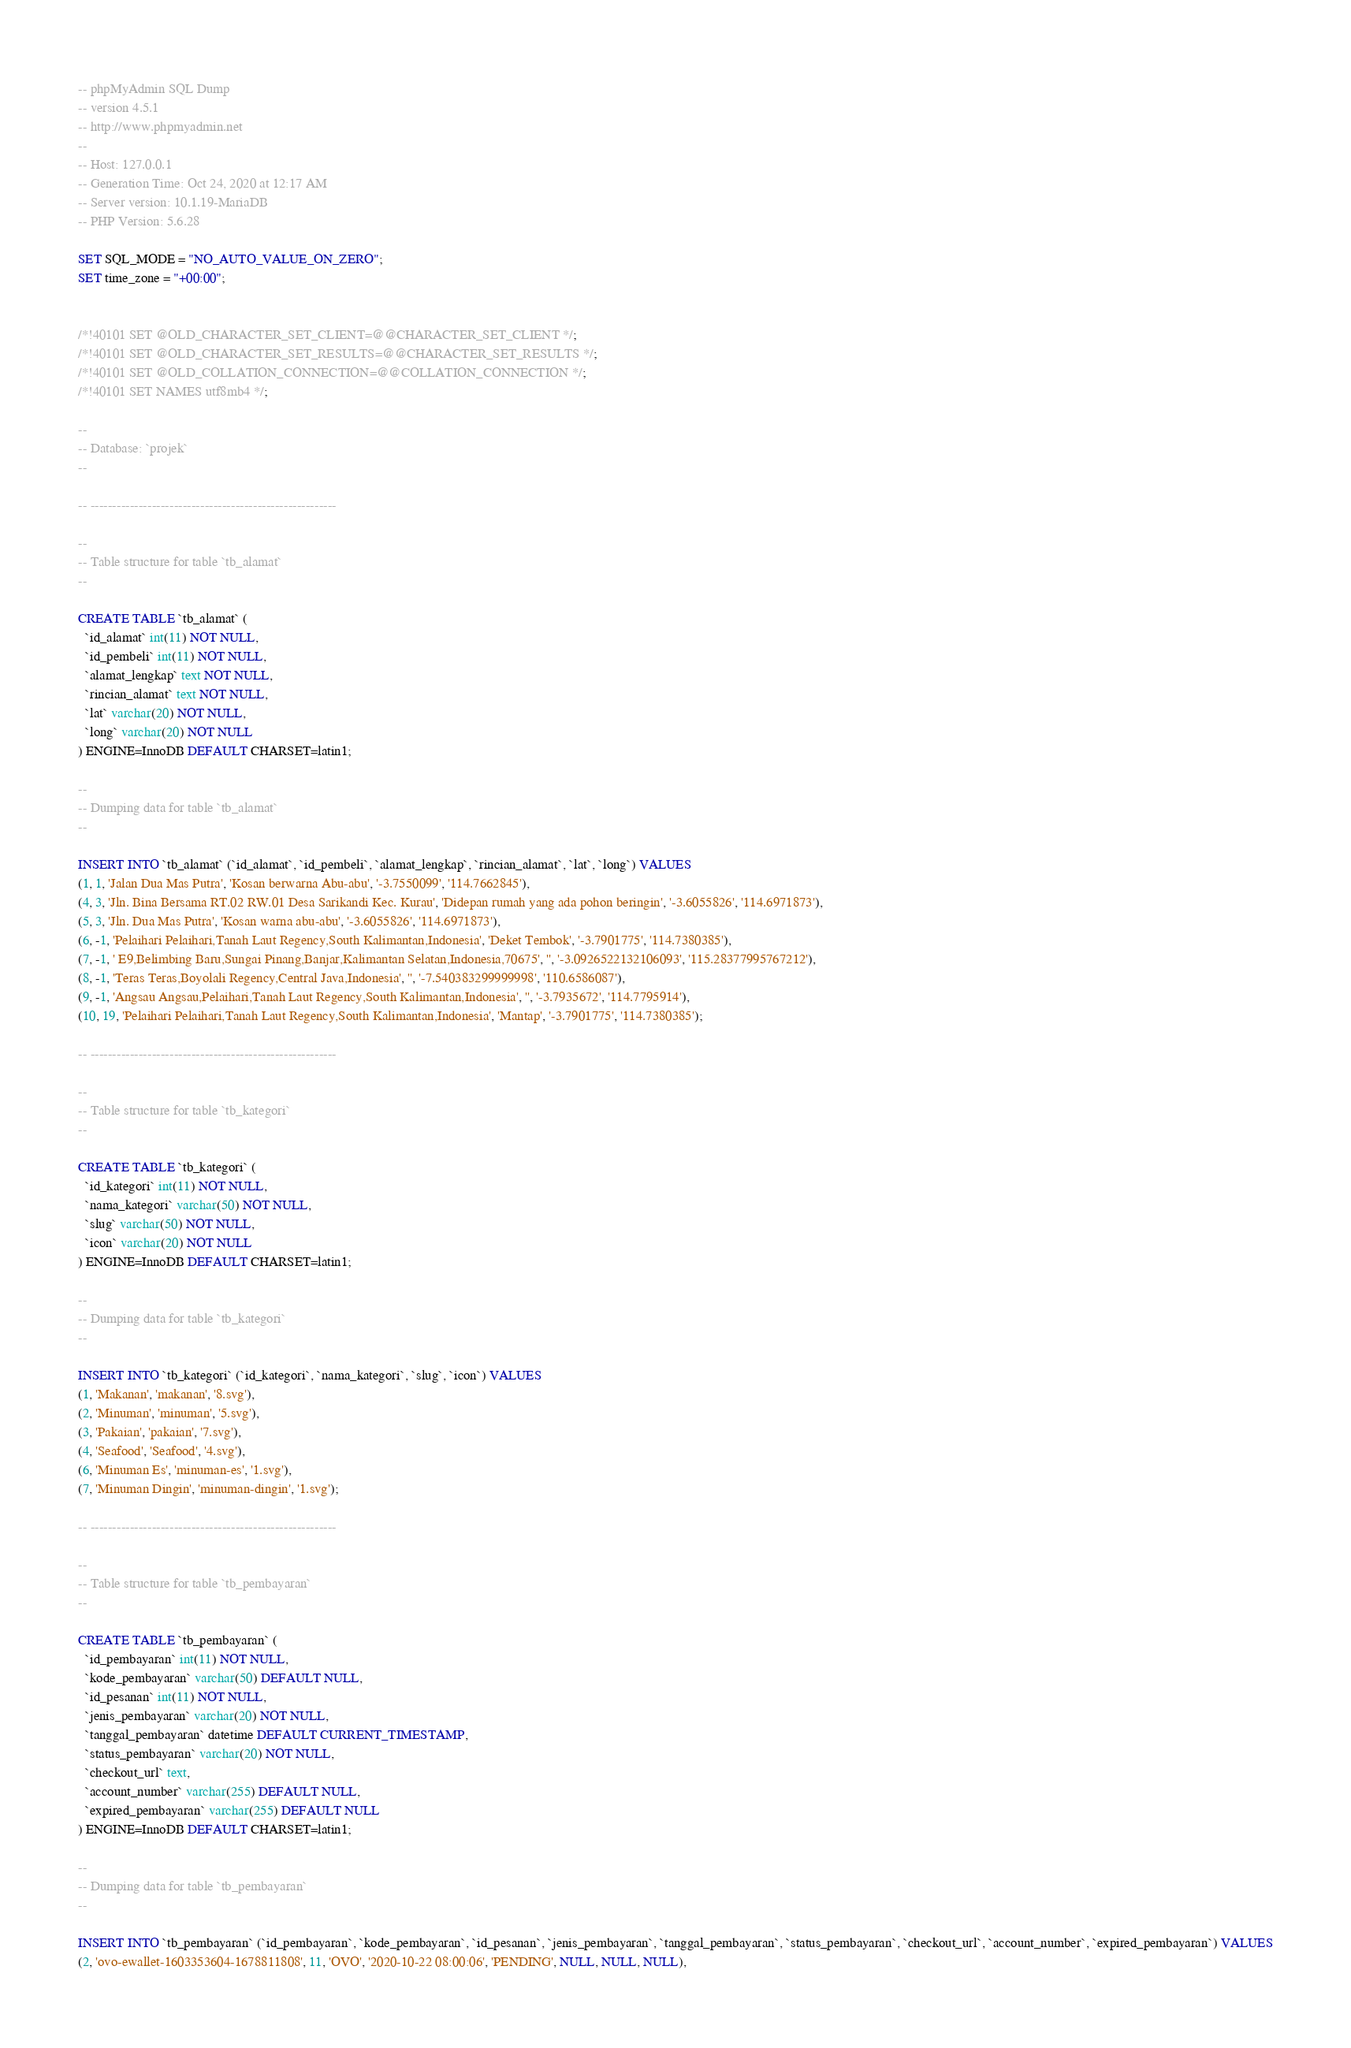<code> <loc_0><loc_0><loc_500><loc_500><_SQL_>-- phpMyAdmin SQL Dump
-- version 4.5.1
-- http://www.phpmyadmin.net
--
-- Host: 127.0.0.1
-- Generation Time: Oct 24, 2020 at 12:17 AM
-- Server version: 10.1.19-MariaDB
-- PHP Version: 5.6.28

SET SQL_MODE = "NO_AUTO_VALUE_ON_ZERO";
SET time_zone = "+00:00";


/*!40101 SET @OLD_CHARACTER_SET_CLIENT=@@CHARACTER_SET_CLIENT */;
/*!40101 SET @OLD_CHARACTER_SET_RESULTS=@@CHARACTER_SET_RESULTS */;
/*!40101 SET @OLD_COLLATION_CONNECTION=@@COLLATION_CONNECTION */;
/*!40101 SET NAMES utf8mb4 */;

--
-- Database: `projek`
--

-- --------------------------------------------------------

--
-- Table structure for table `tb_alamat`
--

CREATE TABLE `tb_alamat` (
  `id_alamat` int(11) NOT NULL,
  `id_pembeli` int(11) NOT NULL,
  `alamat_lengkap` text NOT NULL,
  `rincian_alamat` text NOT NULL,
  `lat` varchar(20) NOT NULL,
  `long` varchar(20) NOT NULL
) ENGINE=InnoDB DEFAULT CHARSET=latin1;

--
-- Dumping data for table `tb_alamat`
--

INSERT INTO `tb_alamat` (`id_alamat`, `id_pembeli`, `alamat_lengkap`, `rincian_alamat`, `lat`, `long`) VALUES
(1, 1, 'Jalan Dua Mas Putra', 'Kosan berwarna Abu-abu', '-3.7550099', '114.7662845'),
(4, 3, 'Jln. Bina Bersama RT.02 RW.01 Desa Sarikandi Kec. Kurau', 'Didepan rumah yang ada pohon beringin', '-3.6055826', '114.6971873'),
(5, 3, 'Jln. Dua Mas Putra', 'Kosan warna abu-abu', '-3.6055826', '114.6971873'),
(6, -1, 'Pelaihari Pelaihari,Tanah Laut Regency,South Kalimantan,Indonesia', 'Deket Tembok', '-3.7901775', '114.7380385'),
(7, -1, ' E9,Belimbing Baru,Sungai Pinang,Banjar,Kalimantan Selatan,Indonesia,70675', '', '-3.0926522132106093', '115.28377995767212'),
(8, -1, 'Teras Teras,Boyolali Regency,Central Java,Indonesia', '', '-7.540383299999998', '110.6586087'),
(9, -1, 'Angsau Angsau,Pelaihari,Tanah Laut Regency,South Kalimantan,Indonesia', '', '-3.7935672', '114.7795914'),
(10, 19, 'Pelaihari Pelaihari,Tanah Laut Regency,South Kalimantan,Indonesia', 'Mantap', '-3.7901775', '114.7380385');

-- --------------------------------------------------------

--
-- Table structure for table `tb_kategori`
--

CREATE TABLE `tb_kategori` (
  `id_kategori` int(11) NOT NULL,
  `nama_kategori` varchar(50) NOT NULL,
  `slug` varchar(50) NOT NULL,
  `icon` varchar(20) NOT NULL
) ENGINE=InnoDB DEFAULT CHARSET=latin1;

--
-- Dumping data for table `tb_kategori`
--

INSERT INTO `tb_kategori` (`id_kategori`, `nama_kategori`, `slug`, `icon`) VALUES
(1, 'Makanan', 'makanan', '8.svg'),
(2, 'Minuman', 'minuman', '5.svg'),
(3, 'Pakaian', 'pakaian', '7.svg'),
(4, 'Seafood', 'Seafood', '4.svg'),
(6, 'Minuman Es', 'minuman-es', '1.svg'),
(7, 'Minuman Dingin', 'minuman-dingin', '1.svg');

-- --------------------------------------------------------

--
-- Table structure for table `tb_pembayaran`
--

CREATE TABLE `tb_pembayaran` (
  `id_pembayaran` int(11) NOT NULL,
  `kode_pembayaran` varchar(50) DEFAULT NULL,
  `id_pesanan` int(11) NOT NULL,
  `jenis_pembayaran` varchar(20) NOT NULL,
  `tanggal_pembayaran` datetime DEFAULT CURRENT_TIMESTAMP,
  `status_pembayaran` varchar(20) NOT NULL,
  `checkout_url` text,
  `account_number` varchar(255) DEFAULT NULL,
  `expired_pembayaran` varchar(255) DEFAULT NULL
) ENGINE=InnoDB DEFAULT CHARSET=latin1;

--
-- Dumping data for table `tb_pembayaran`
--

INSERT INTO `tb_pembayaran` (`id_pembayaran`, `kode_pembayaran`, `id_pesanan`, `jenis_pembayaran`, `tanggal_pembayaran`, `status_pembayaran`, `checkout_url`, `account_number`, `expired_pembayaran`) VALUES
(2, 'ovo-ewallet-1603353604-1678811808', 11, 'OVO', '2020-10-22 08:00:06', 'PENDING', NULL, NULL, NULL),</code> 